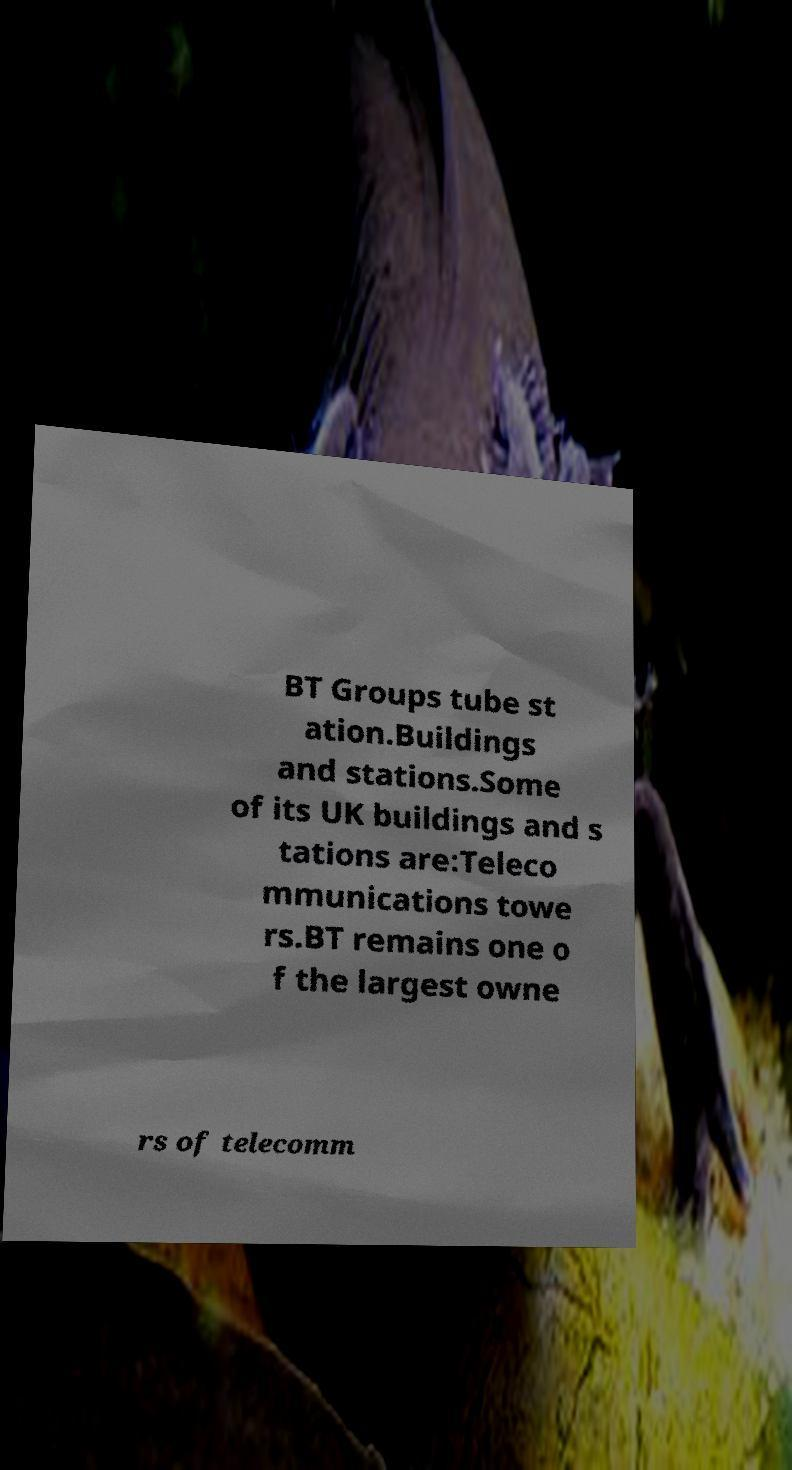Could you assist in decoding the text presented in this image and type it out clearly? BT Groups tube st ation.Buildings and stations.Some of its UK buildings and s tations are:Teleco mmunications towe rs.BT remains one o f the largest owne rs of telecomm 